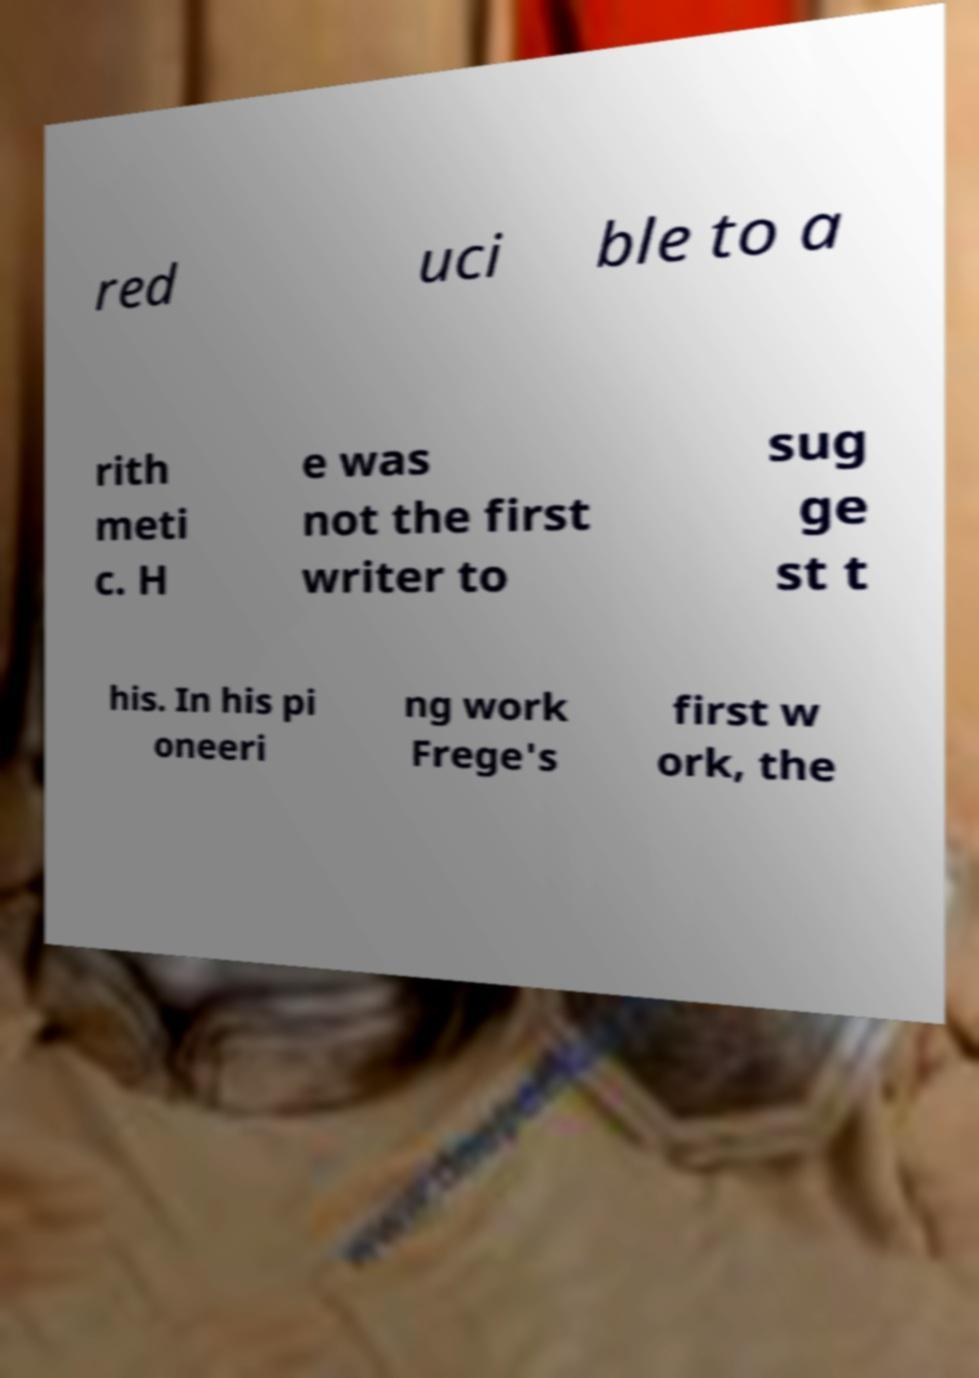Can you accurately transcribe the text from the provided image for me? red uci ble to a rith meti c. H e was not the first writer to sug ge st t his. In his pi oneeri ng work Frege's first w ork, the 